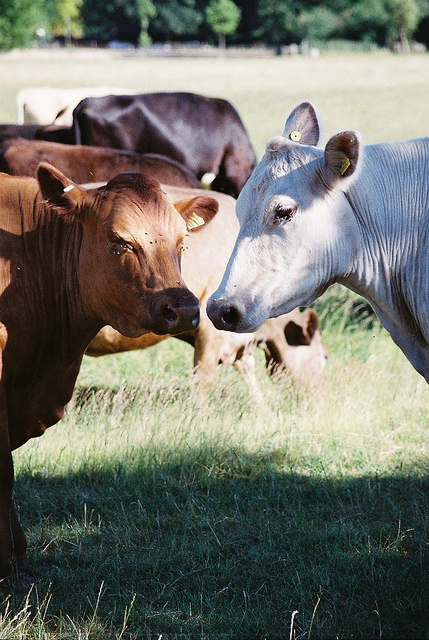Describe the objects in this image and their specific colors. I can see cow in black, maroon, brown, and tan tones, cow in black, lightgray, darkgray, and gray tones, cow in black, lightgray, and tan tones, cow in black, darkgray, gray, and purple tones, and cow in black, brown, and maroon tones in this image. 